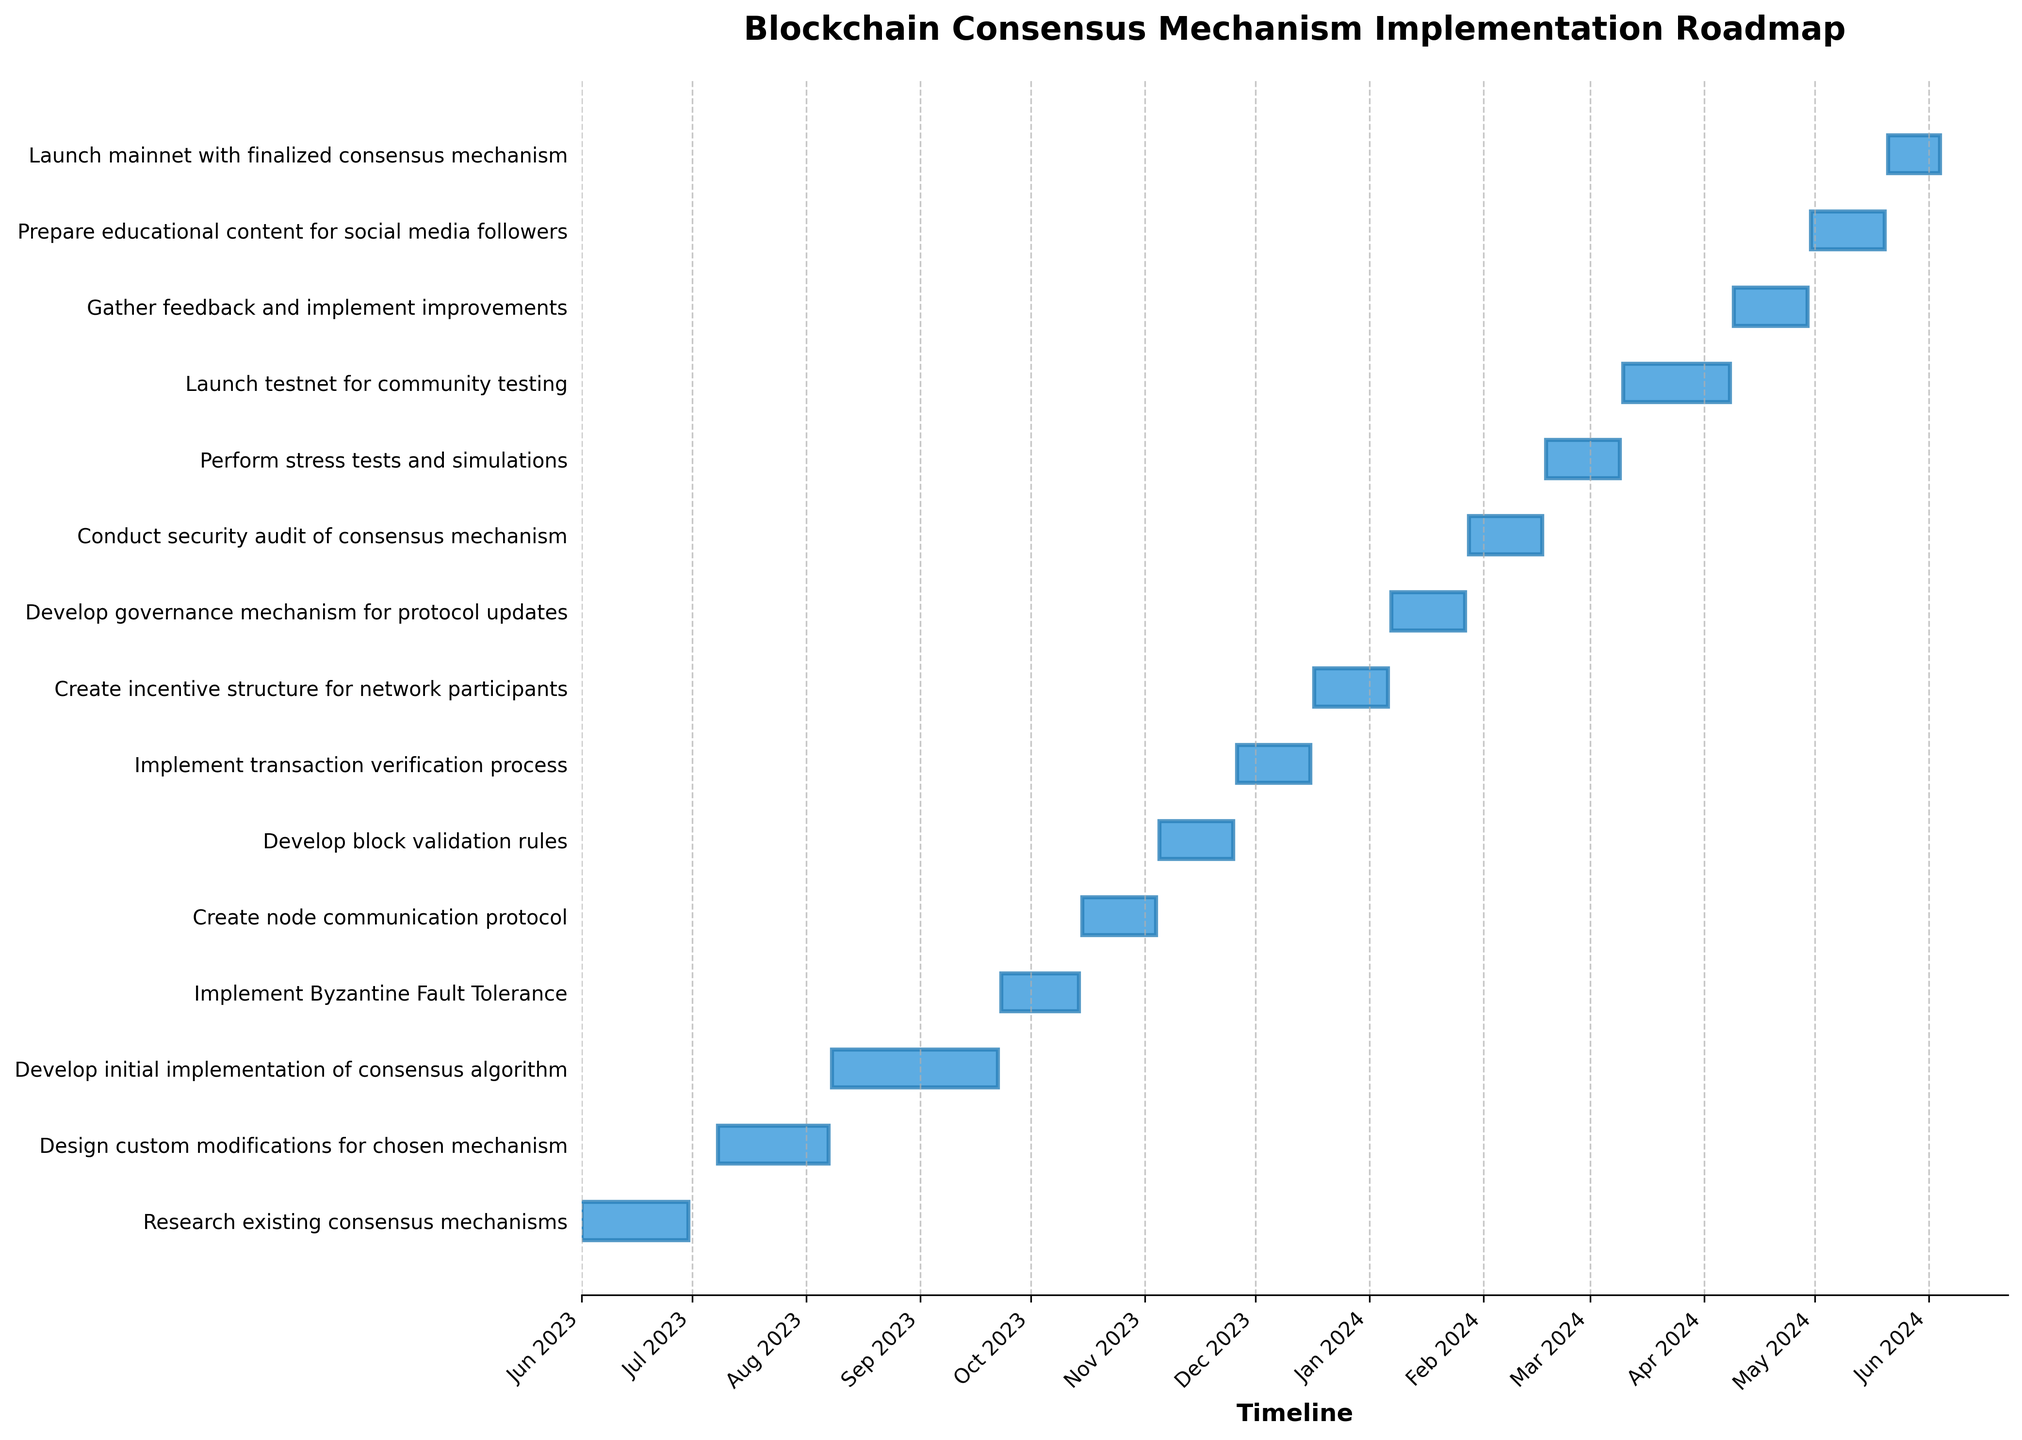What is the title of the Gantt Chart? The title is usually found at the top of a chart. It provides a summary of what the chart represents. By looking at the top of the figure, you can read the title.
Answer: Blockchain Consensus Mechanism Implementation Roadmap How many tasks are scheduled to be completed in 2023? To determine this, look at the end dates of all tasks and count those which fall within the year 2023. Count all tasks ending before 2024.
Answer: 8 tasks Which task has the shortest duration? This requires identifying and comparing the durations of all tasks. The task with the smallest number of days is the one with the shortest duration.
Answer: Launch mainnet with finalized consensus mechanism When does the task "Implement Byzantine Fault Tolerance" start and end? To find the start and end dates of this specific task, locate it on the y-axis and then read the corresponding dates on the x-axis for its horizontal bar.
Answer: 2023-09-23 to 2023-10-14 How many days does the "Develop initial implementation of consensus algorithm" task last? Identify the task on the y-axis, then check the start date and end date for its horizontal bar. Subtract the start date from the end date to get the duration.
Answer: 46 days Which tasks are scheduled to start in October 2023? Identify the tasks by their start date falling in October 2023. Look at the x-axis for this specific month and check which tasks have bars starting in that range.
Answer: Create node communication protocol What is the total duration for the tasks "Create incentive structure for network participants" and "Develop governance mechanism for protocol updates"? Sum the durations of the two tasks. These durations are indicated in days in the table provided.
Answer: 42 days Which task finishes right before the "Create node communication protocol" task begins? Identify the start date for "Create node communication protocol" and find the task that ends one day before this start date.
Answer: Implement Byzantine Fault Tolerance How long does the "Launch testnet for community testing" task last in days? Locate the task on the y-axis and compare its start and end dates on the x-axis. Calculate the difference between the start and end dates to determine its duration in days.
Answer: 30 days When is the "Prepare educational content for social media followers" task set to be completed? Find the task on the y-axis and read its corresponding end date on the x-axis. The end date indicates its completion.
Answer: 2024-05-20 